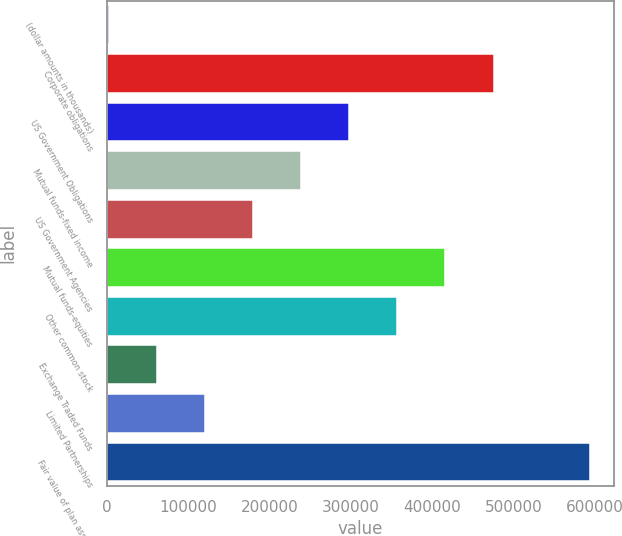Convert chart to OTSL. <chart><loc_0><loc_0><loc_500><loc_500><bar_chart><fcel>(dollar amounts in thousands)<fcel>Corporate obligations<fcel>US Government Obligations<fcel>Mutual funds-fixed income<fcel>US Government Agencies<fcel>Mutual funds-equities<fcel>Other common stock<fcel>Exchange Traded Funds<fcel>Limited Partnerships<fcel>Fair value of plan assets<nl><fcel>2015<fcel>475777<fcel>298116<fcel>238896<fcel>179676<fcel>416556<fcel>357336<fcel>61235.2<fcel>120455<fcel>594217<nl></chart> 